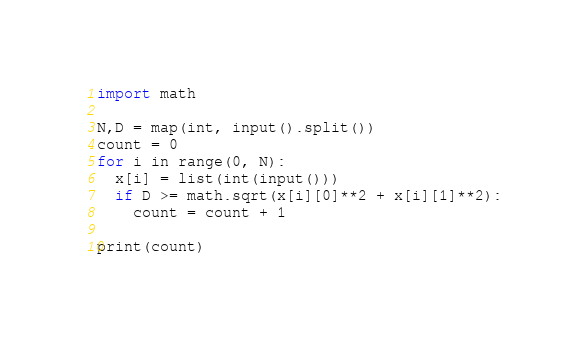<code> <loc_0><loc_0><loc_500><loc_500><_Python_>import math
 
N,D = map(int, input().split())
count = 0
for i in range(0, N):
  x[i] = list(int(input()))
  if D >= math.sqrt(x[i][0]**2 + x[i][1]**2):
    count = count + 1
 
print(count)</code> 